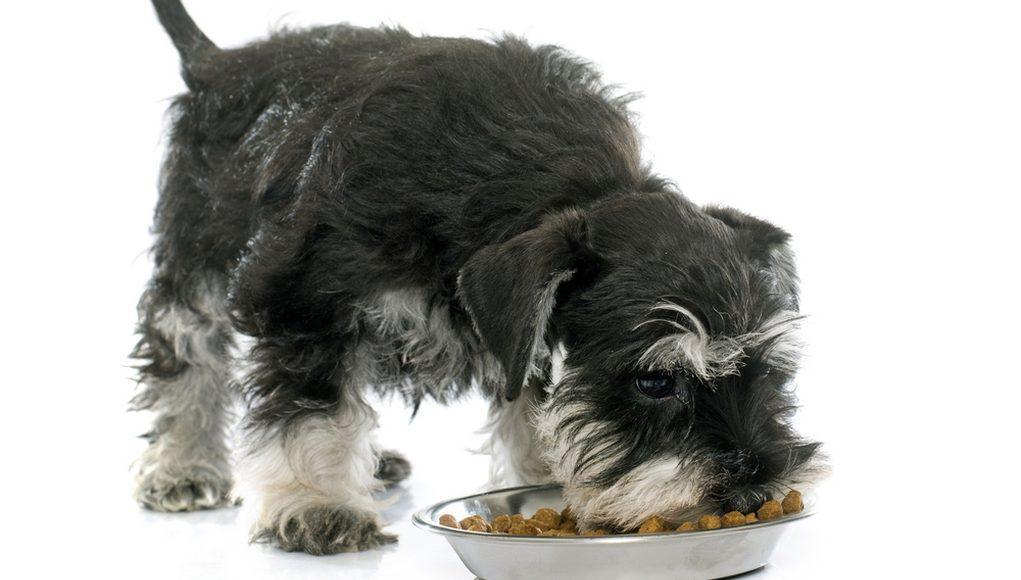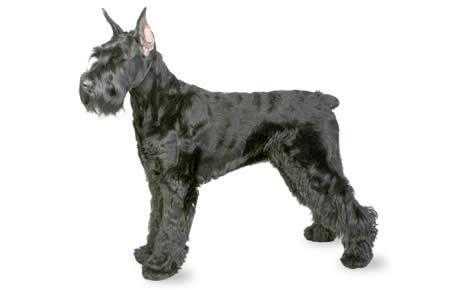The first image is the image on the left, the second image is the image on the right. For the images displayed, is the sentence "An image shows a standing schnauzer dog posed with dog food." factually correct? Answer yes or no. Yes. The first image is the image on the left, the second image is the image on the right. Analyze the images presented: Is the assertion "The dogs are facing generally in the opposite direction" valid? Answer yes or no. Yes. 